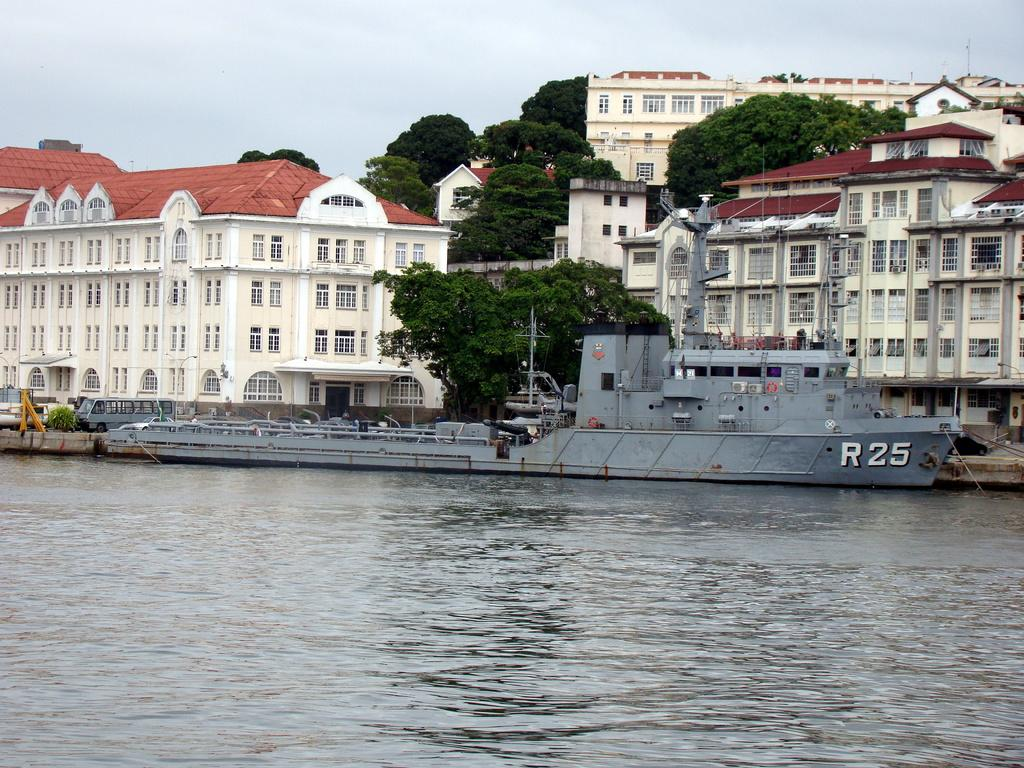What type of structures can be seen in the image? There are buildings in the image. What other natural elements are present in the image? There are trees in the image. What mode of transportation can be seen in the image? There are vehicles in the image. What is located in the water in the image? There is a ship in the water in the image. What part of the natural environment is visible in the image? The sky is visible in the image. What can be seen in the sky? There are clouds in the sky. What type of man-made object is present in the image? There is a street light in the image. What type of vertical structures are present in the image? There are poles in the image. What type of barrier can be seen in the image? There is fencing in the image. What type of creature is shown interacting with the street light in the image? There is no creature shown interacting with the street light in the image; only the street light and other objects are present. What is the cause of the loss experienced by the person in the image? There is no person or loss mentioned in the image; it only contains buildings, trees, vehicles, a ship, the sky, clouds, a street light, poles, and fencing. 